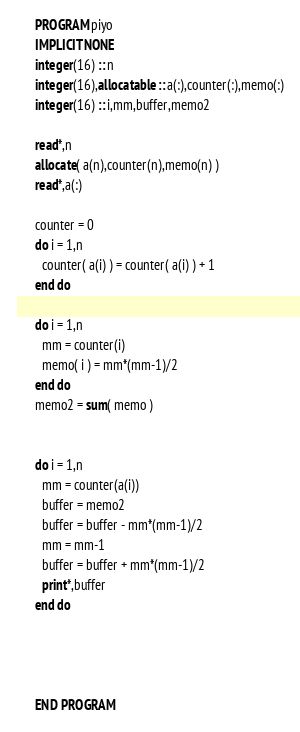Convert code to text. <code><loc_0><loc_0><loc_500><loc_500><_FORTRAN_>      PROGRAM piyo
      IMPLICIT NONE
      integer(16) :: n
      integer(16),allocatable :: a(:),counter(:),memo(:)
      integer(16) :: i,mm,buffer,memo2
      
      read*,n
      allocate( a(n),counter(n),memo(n) )
      read*,a(:)
      
      counter = 0
      do i = 1,n
        counter( a(i) ) = counter( a(i) ) + 1
      end do
      
      do i = 1,n
        mm = counter(i)
        memo( i ) = mm*(mm-1)/2
      end do
      memo2 = sum( memo )
      
      
      do i = 1,n
        mm = counter(a(i))
        buffer = memo2
        buffer = buffer - mm*(mm-1)/2
        mm = mm-1
        buffer = buffer + mm*(mm-1)/2
        print*,buffer
      end do
      
      
      
      
      END PROGRAM</code> 